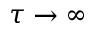<formula> <loc_0><loc_0><loc_500><loc_500>\tau \to \infty</formula> 